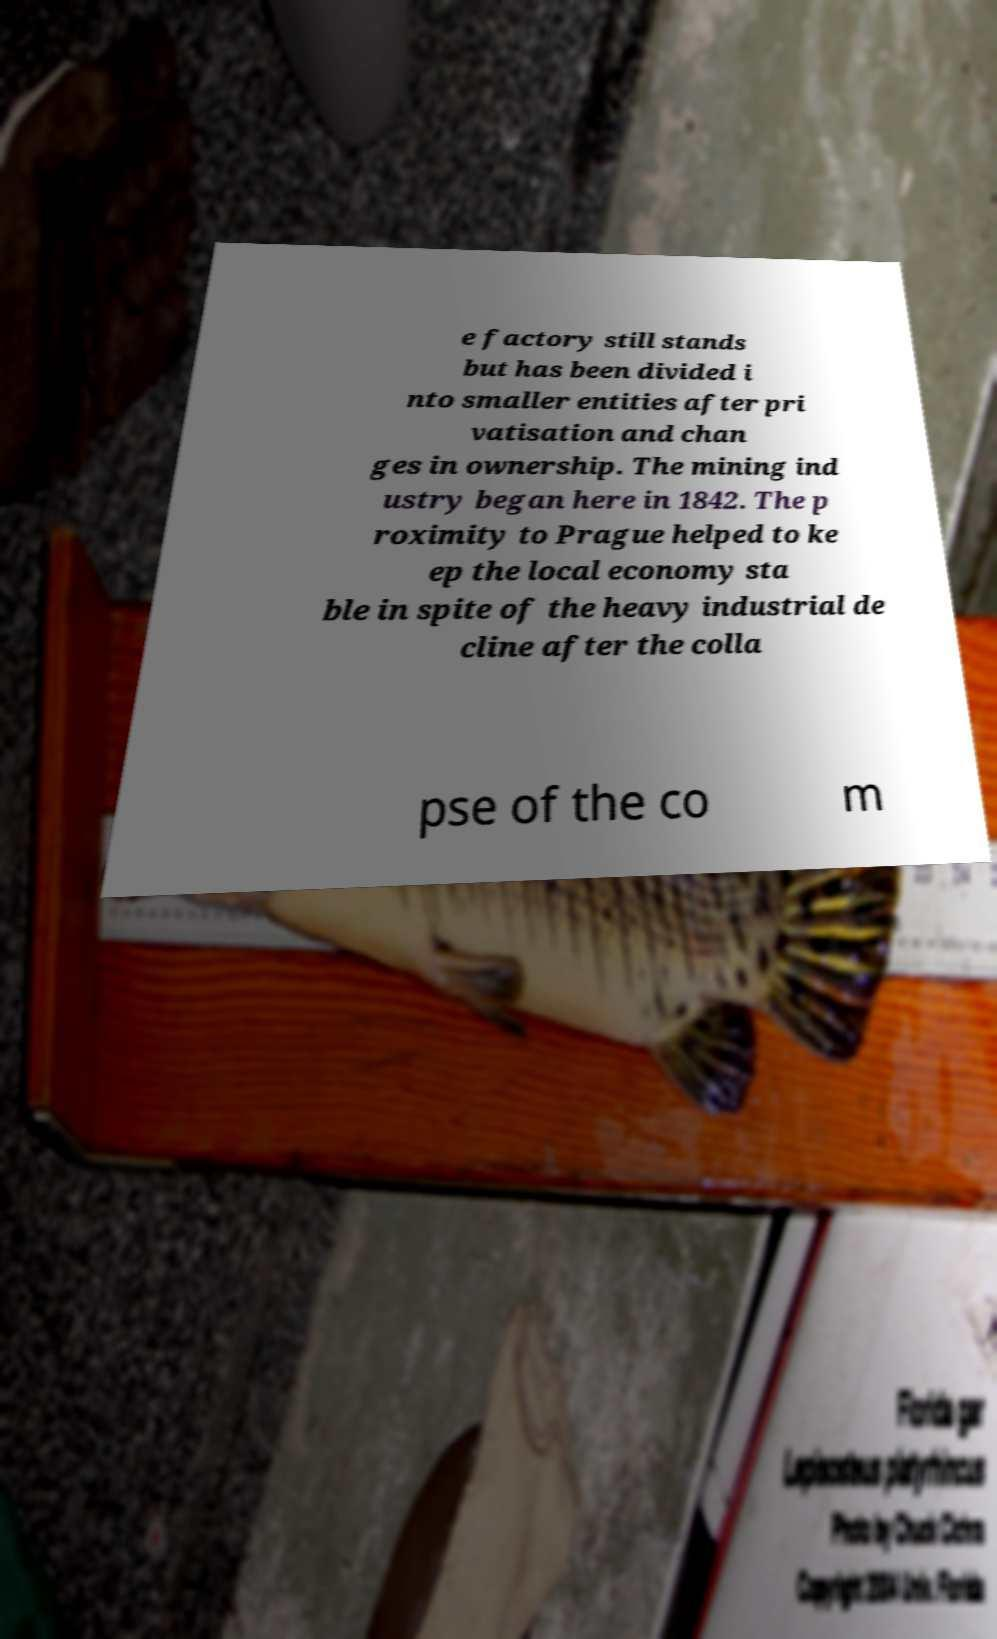Can you read and provide the text displayed in the image?This photo seems to have some interesting text. Can you extract and type it out for me? e factory still stands but has been divided i nto smaller entities after pri vatisation and chan ges in ownership. The mining ind ustry began here in 1842. The p roximity to Prague helped to ke ep the local economy sta ble in spite of the heavy industrial de cline after the colla pse of the co m 